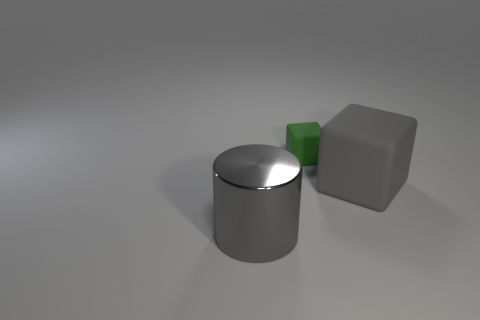There is a gray thing to the right of the gray shiny object; what is its size?
Your answer should be compact. Large. How many green objects are metal cylinders or rubber objects?
Ensure brevity in your answer.  1. Are there any other things that are the same material as the big gray cylinder?
Offer a terse response. No. There is a tiny green thing that is the same shape as the large gray rubber object; what material is it?
Provide a succinct answer. Rubber. Are there an equal number of large objects that are on the left side of the large block and gray shiny cubes?
Your response must be concise. No. How big is the thing that is right of the large gray metallic cylinder and in front of the green object?
Ensure brevity in your answer.  Large. Is there anything else of the same color as the large metallic object?
Your answer should be very brief. Yes. What size is the rubber block behind the block in front of the tiny matte thing?
Provide a short and direct response. Small. What is the color of the thing that is in front of the green block and to the left of the large gray block?
Make the answer very short. Gray. What number of other objects are the same size as the gray rubber block?
Provide a succinct answer. 1. 